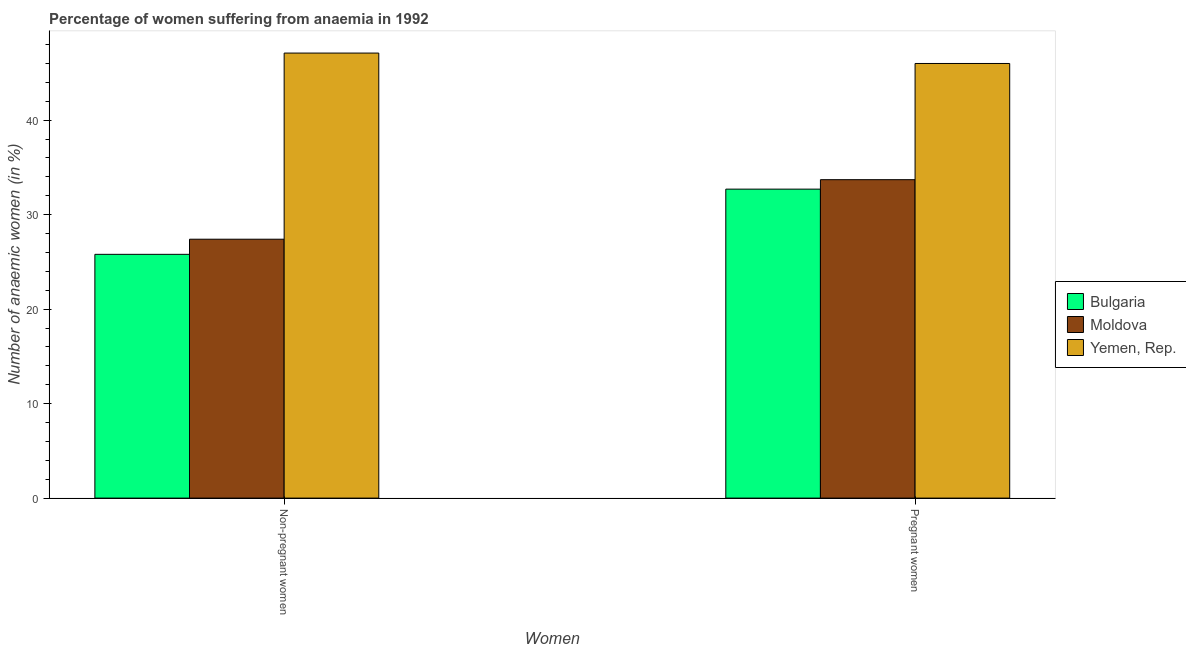How many different coloured bars are there?
Your answer should be very brief. 3. How many groups of bars are there?
Ensure brevity in your answer.  2. Are the number of bars per tick equal to the number of legend labels?
Provide a short and direct response. Yes. Are the number of bars on each tick of the X-axis equal?
Your answer should be very brief. Yes. What is the label of the 2nd group of bars from the left?
Your answer should be compact. Pregnant women. What is the percentage of non-pregnant anaemic women in Moldova?
Keep it short and to the point. 27.4. Across all countries, what is the maximum percentage of pregnant anaemic women?
Give a very brief answer. 46. Across all countries, what is the minimum percentage of non-pregnant anaemic women?
Make the answer very short. 25.8. In which country was the percentage of non-pregnant anaemic women maximum?
Your answer should be very brief. Yemen, Rep. What is the total percentage of pregnant anaemic women in the graph?
Your answer should be compact. 112.4. What is the difference between the percentage of non-pregnant anaemic women in Yemen, Rep. and that in Bulgaria?
Provide a succinct answer. 21.3. What is the difference between the percentage of non-pregnant anaemic women in Moldova and the percentage of pregnant anaemic women in Bulgaria?
Keep it short and to the point. -5.3. What is the average percentage of non-pregnant anaemic women per country?
Provide a succinct answer. 33.43. What is the difference between the percentage of pregnant anaemic women and percentage of non-pregnant anaemic women in Bulgaria?
Give a very brief answer. 6.9. What is the ratio of the percentage of pregnant anaemic women in Yemen, Rep. to that in Moldova?
Provide a succinct answer. 1.36. Is the percentage of non-pregnant anaemic women in Moldova less than that in Bulgaria?
Offer a terse response. No. What does the 3rd bar from the left in Pregnant women represents?
Give a very brief answer. Yemen, Rep. What does the 3rd bar from the right in Non-pregnant women represents?
Offer a terse response. Bulgaria. Are all the bars in the graph horizontal?
Ensure brevity in your answer.  No. How many countries are there in the graph?
Make the answer very short. 3. What is the difference between two consecutive major ticks on the Y-axis?
Provide a succinct answer. 10. Does the graph contain any zero values?
Keep it short and to the point. No. How many legend labels are there?
Your answer should be very brief. 3. What is the title of the graph?
Ensure brevity in your answer.  Percentage of women suffering from anaemia in 1992. Does "Romania" appear as one of the legend labels in the graph?
Provide a short and direct response. No. What is the label or title of the X-axis?
Your answer should be compact. Women. What is the label or title of the Y-axis?
Ensure brevity in your answer.  Number of anaemic women (in %). What is the Number of anaemic women (in %) of Bulgaria in Non-pregnant women?
Make the answer very short. 25.8. What is the Number of anaemic women (in %) of Moldova in Non-pregnant women?
Ensure brevity in your answer.  27.4. What is the Number of anaemic women (in %) of Yemen, Rep. in Non-pregnant women?
Offer a very short reply. 47.1. What is the Number of anaemic women (in %) in Bulgaria in Pregnant women?
Keep it short and to the point. 32.7. What is the Number of anaemic women (in %) of Moldova in Pregnant women?
Provide a succinct answer. 33.7. Across all Women, what is the maximum Number of anaemic women (in %) of Bulgaria?
Ensure brevity in your answer.  32.7. Across all Women, what is the maximum Number of anaemic women (in %) in Moldova?
Provide a short and direct response. 33.7. Across all Women, what is the maximum Number of anaemic women (in %) of Yemen, Rep.?
Provide a succinct answer. 47.1. Across all Women, what is the minimum Number of anaemic women (in %) of Bulgaria?
Keep it short and to the point. 25.8. Across all Women, what is the minimum Number of anaemic women (in %) of Moldova?
Make the answer very short. 27.4. Across all Women, what is the minimum Number of anaemic women (in %) of Yemen, Rep.?
Make the answer very short. 46. What is the total Number of anaemic women (in %) of Bulgaria in the graph?
Provide a succinct answer. 58.5. What is the total Number of anaemic women (in %) in Moldova in the graph?
Provide a succinct answer. 61.1. What is the total Number of anaemic women (in %) in Yemen, Rep. in the graph?
Keep it short and to the point. 93.1. What is the difference between the Number of anaemic women (in %) in Moldova in Non-pregnant women and that in Pregnant women?
Ensure brevity in your answer.  -6.3. What is the difference between the Number of anaemic women (in %) in Bulgaria in Non-pregnant women and the Number of anaemic women (in %) in Yemen, Rep. in Pregnant women?
Your answer should be very brief. -20.2. What is the difference between the Number of anaemic women (in %) in Moldova in Non-pregnant women and the Number of anaemic women (in %) in Yemen, Rep. in Pregnant women?
Give a very brief answer. -18.6. What is the average Number of anaemic women (in %) of Bulgaria per Women?
Give a very brief answer. 29.25. What is the average Number of anaemic women (in %) of Moldova per Women?
Offer a very short reply. 30.55. What is the average Number of anaemic women (in %) in Yemen, Rep. per Women?
Your answer should be compact. 46.55. What is the difference between the Number of anaemic women (in %) of Bulgaria and Number of anaemic women (in %) of Yemen, Rep. in Non-pregnant women?
Ensure brevity in your answer.  -21.3. What is the difference between the Number of anaemic women (in %) in Moldova and Number of anaemic women (in %) in Yemen, Rep. in Non-pregnant women?
Offer a terse response. -19.7. What is the ratio of the Number of anaemic women (in %) of Bulgaria in Non-pregnant women to that in Pregnant women?
Keep it short and to the point. 0.79. What is the ratio of the Number of anaemic women (in %) in Moldova in Non-pregnant women to that in Pregnant women?
Ensure brevity in your answer.  0.81. What is the ratio of the Number of anaemic women (in %) of Yemen, Rep. in Non-pregnant women to that in Pregnant women?
Your answer should be very brief. 1.02. What is the difference between the highest and the second highest Number of anaemic women (in %) of Bulgaria?
Ensure brevity in your answer.  6.9. What is the difference between the highest and the second highest Number of anaemic women (in %) of Yemen, Rep.?
Ensure brevity in your answer.  1.1. What is the difference between the highest and the lowest Number of anaemic women (in %) in Moldova?
Ensure brevity in your answer.  6.3. 